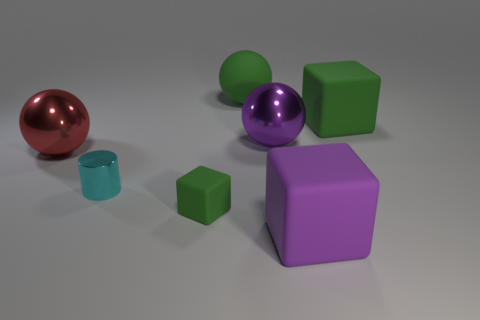Add 3 big green rubber balls. How many objects exist? 10 Subtract all cubes. How many objects are left? 4 Add 3 green matte spheres. How many green matte spheres exist? 4 Subtract 0 green cylinders. How many objects are left? 7 Subtract all tiny matte cylinders. Subtract all small cubes. How many objects are left? 6 Add 2 purple rubber blocks. How many purple rubber blocks are left? 3 